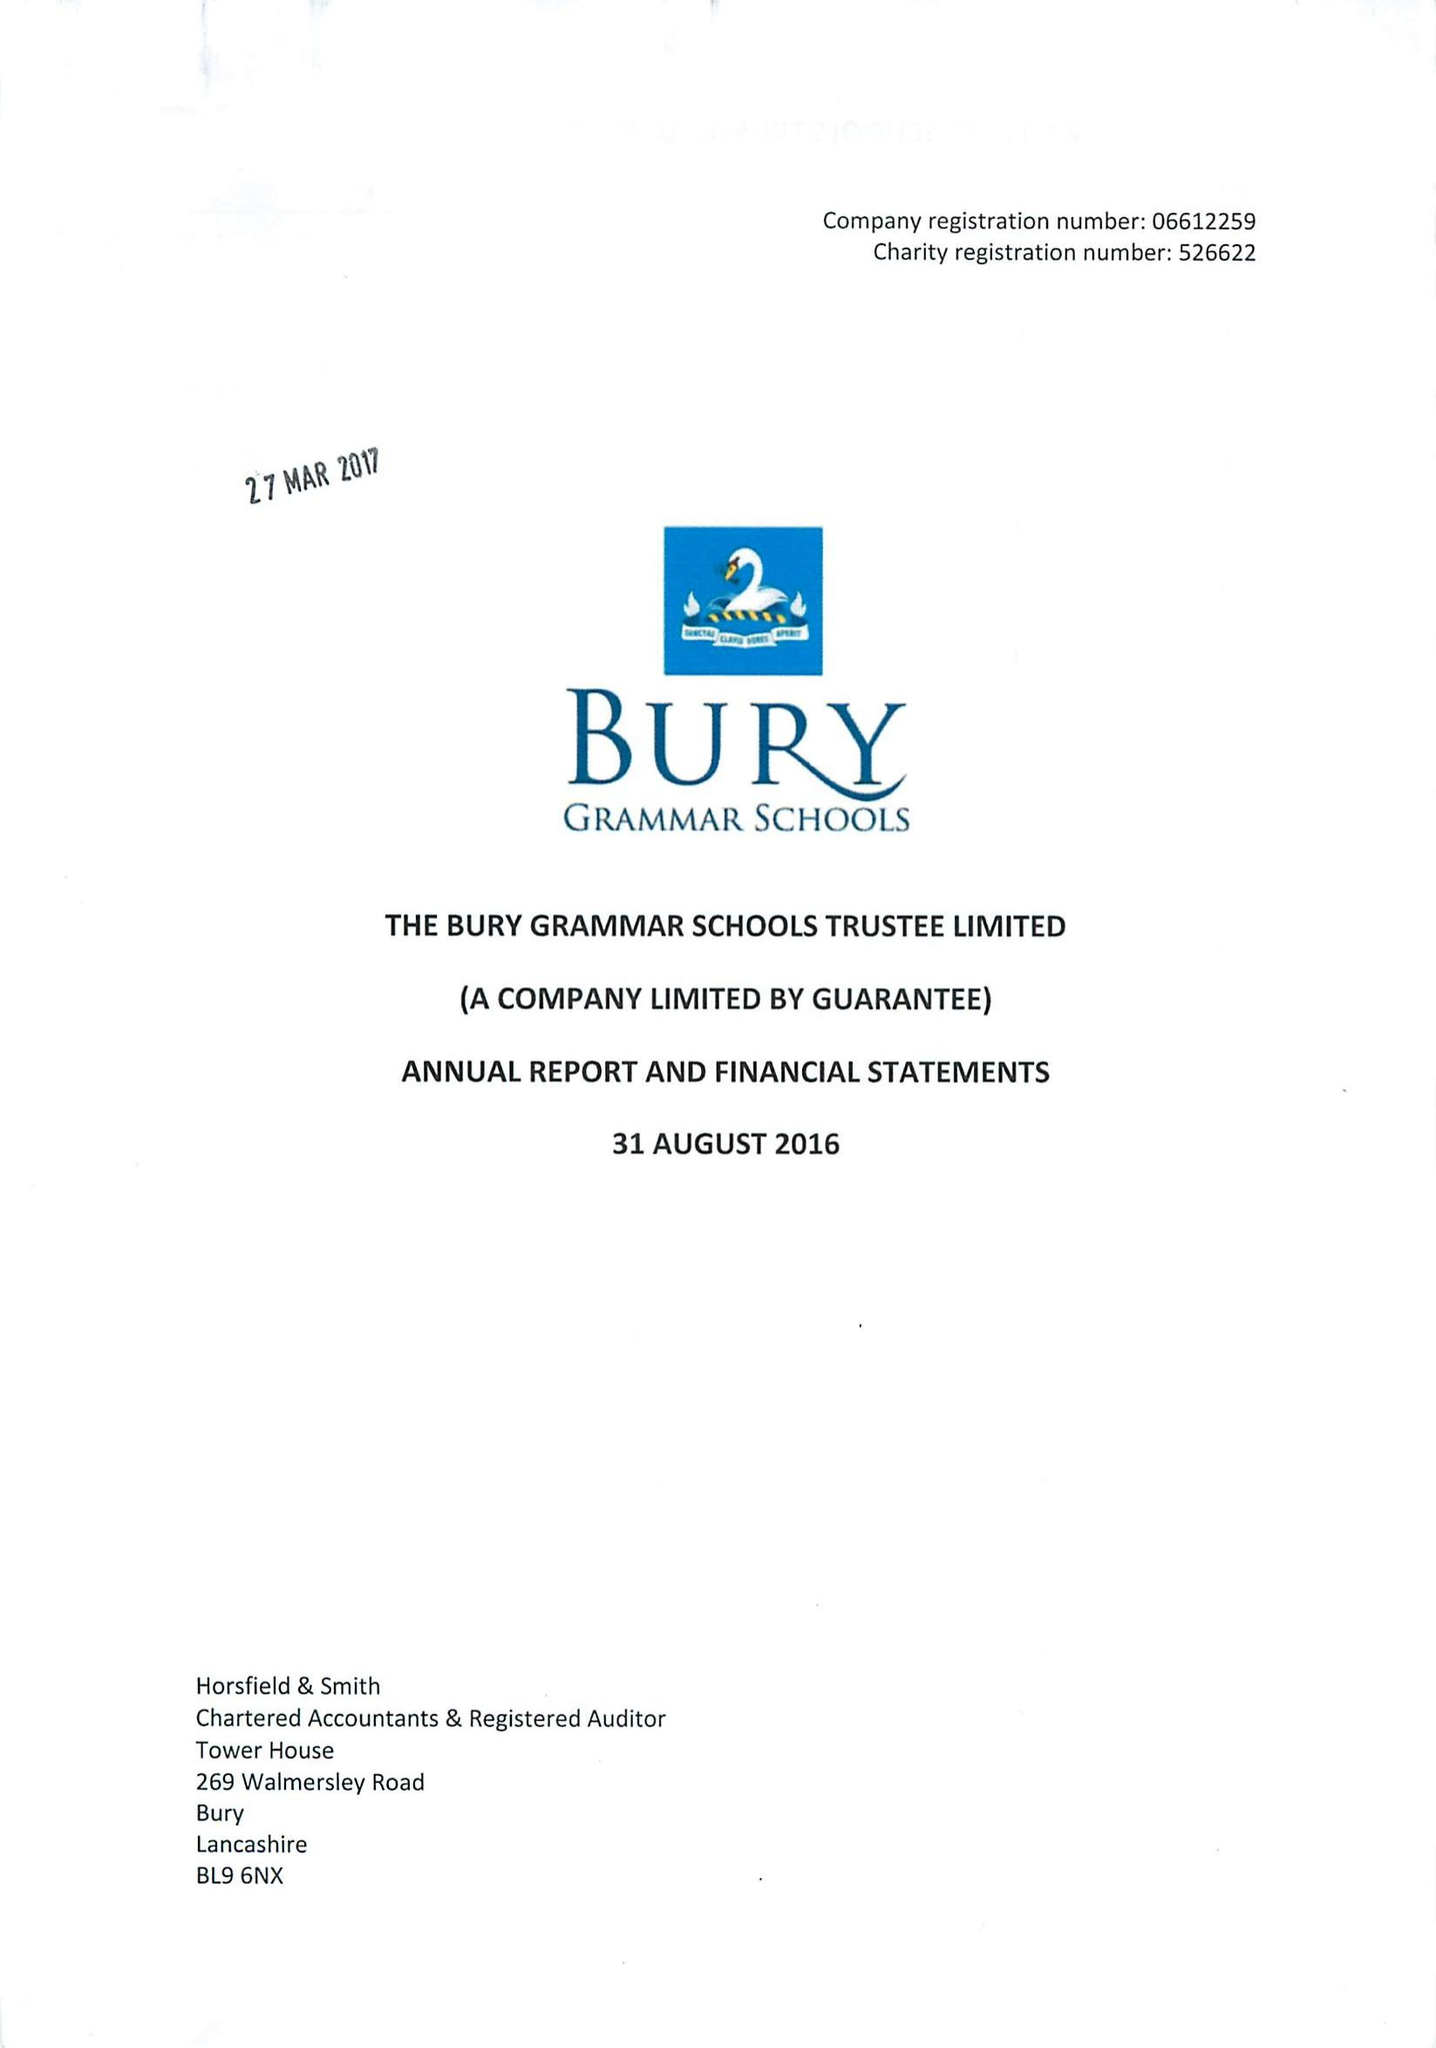What is the value for the address__postcode?
Answer the question using a single word or phrase. BL9 0HG 